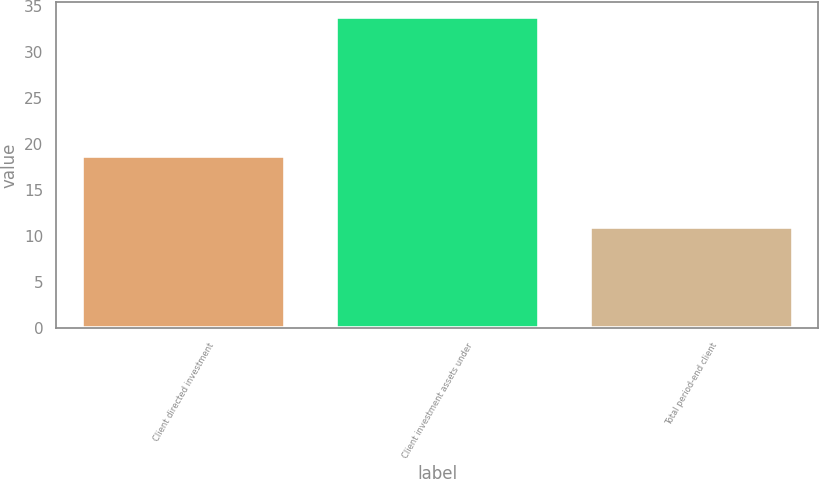<chart> <loc_0><loc_0><loc_500><loc_500><bar_chart><fcel>Client directed investment<fcel>Client investment assets under<fcel>Total period-end client<nl><fcel>18.7<fcel>33.8<fcel>11<nl></chart> 